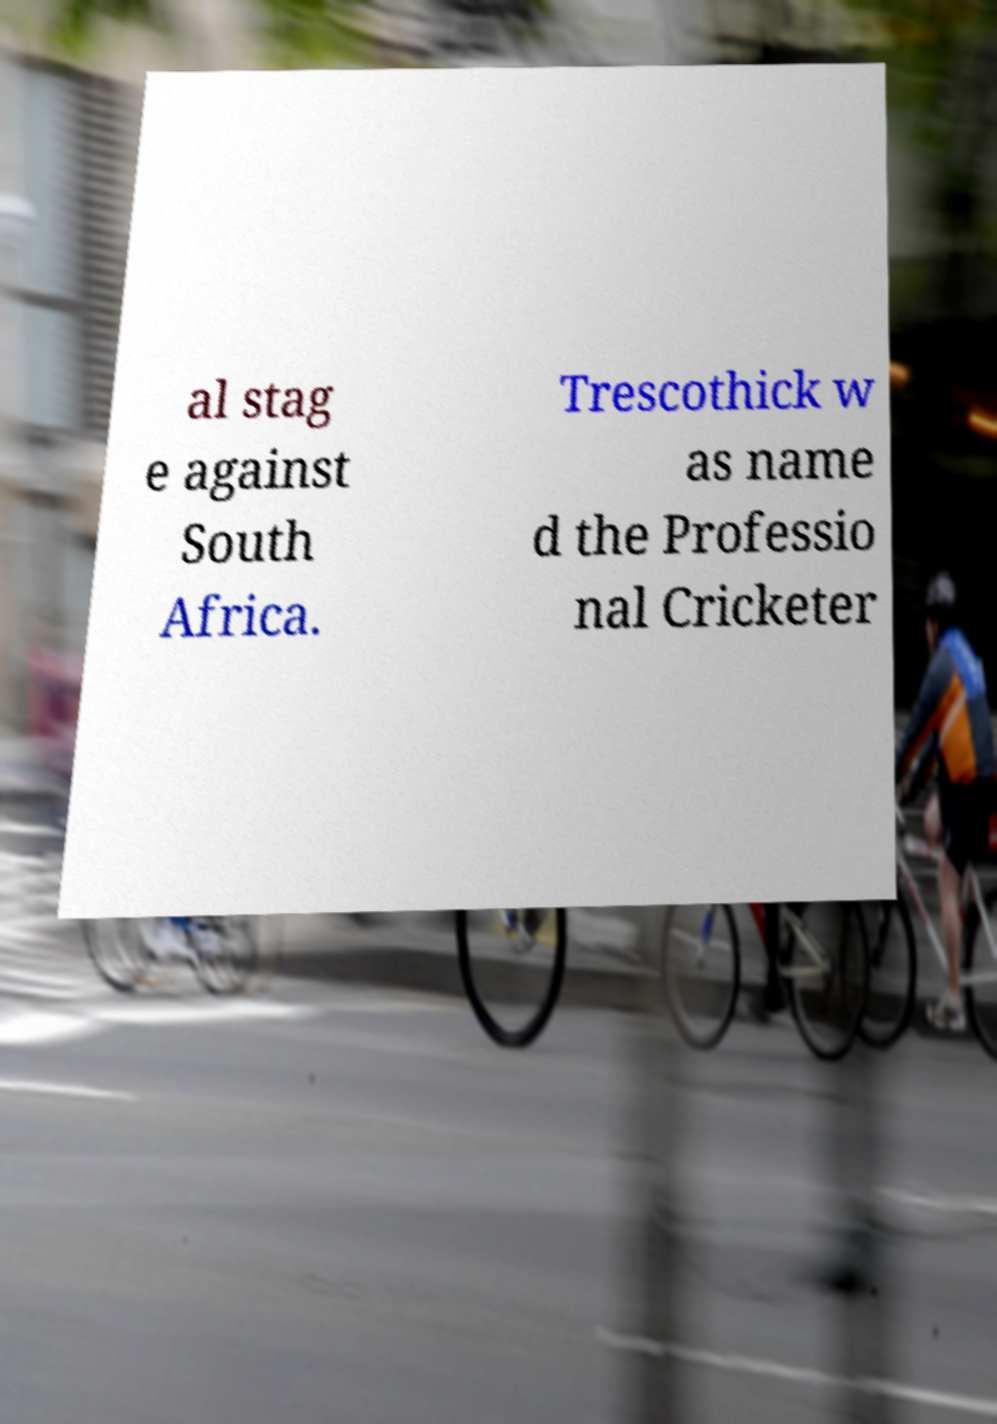What messages or text are displayed in this image? I need them in a readable, typed format. al stag e against South Africa. Trescothick w as name d the Professio nal Cricketer 